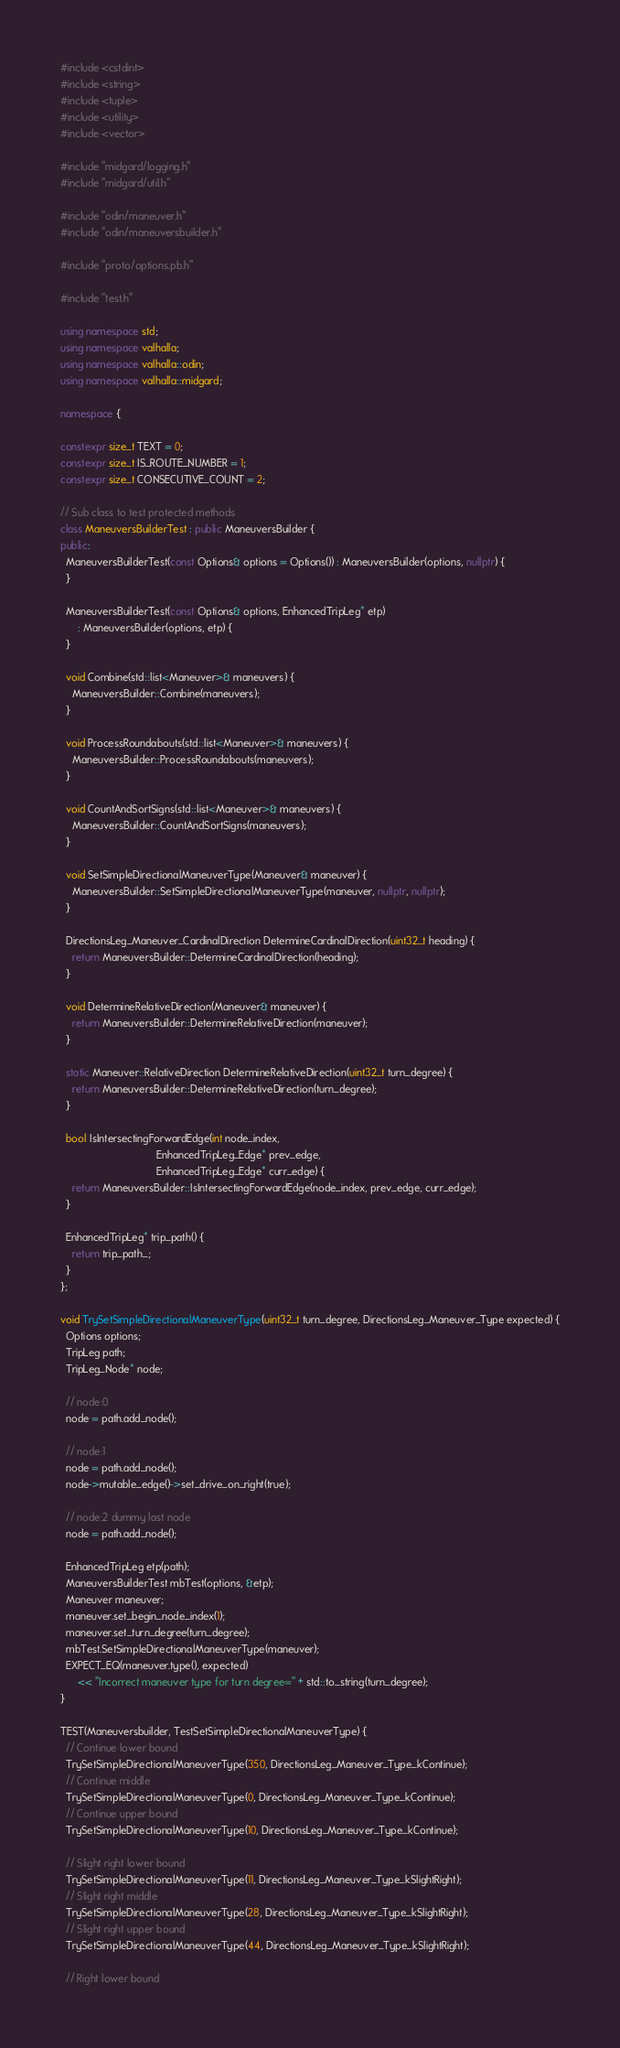Convert code to text. <code><loc_0><loc_0><loc_500><loc_500><_C++_>#include <cstdint>
#include <string>
#include <tuple>
#include <utility>
#include <vector>

#include "midgard/logging.h"
#include "midgard/util.h"

#include "odin/maneuver.h"
#include "odin/maneuversbuilder.h"

#include "proto/options.pb.h"

#include "test.h"

using namespace std;
using namespace valhalla;
using namespace valhalla::odin;
using namespace valhalla::midgard;

namespace {

constexpr size_t TEXT = 0;
constexpr size_t IS_ROUTE_NUMBER = 1;
constexpr size_t CONSECUTIVE_COUNT = 2;

// Sub class to test protected methods
class ManeuversBuilderTest : public ManeuversBuilder {
public:
  ManeuversBuilderTest(const Options& options = Options()) : ManeuversBuilder(options, nullptr) {
  }

  ManeuversBuilderTest(const Options& options, EnhancedTripLeg* etp)
      : ManeuversBuilder(options, etp) {
  }

  void Combine(std::list<Maneuver>& maneuvers) {
    ManeuversBuilder::Combine(maneuvers);
  }

  void ProcessRoundabouts(std::list<Maneuver>& maneuvers) {
    ManeuversBuilder::ProcessRoundabouts(maneuvers);
  }

  void CountAndSortSigns(std::list<Maneuver>& maneuvers) {
    ManeuversBuilder::CountAndSortSigns(maneuvers);
  }

  void SetSimpleDirectionalManeuverType(Maneuver& maneuver) {
    ManeuversBuilder::SetSimpleDirectionalManeuverType(maneuver, nullptr, nullptr);
  }

  DirectionsLeg_Maneuver_CardinalDirection DetermineCardinalDirection(uint32_t heading) {
    return ManeuversBuilder::DetermineCardinalDirection(heading);
  }

  void DetermineRelativeDirection(Maneuver& maneuver) {
    return ManeuversBuilder::DetermineRelativeDirection(maneuver);
  }

  static Maneuver::RelativeDirection DetermineRelativeDirection(uint32_t turn_degree) {
    return ManeuversBuilder::DetermineRelativeDirection(turn_degree);
  }

  bool IsIntersectingForwardEdge(int node_index,
                                 EnhancedTripLeg_Edge* prev_edge,
                                 EnhancedTripLeg_Edge* curr_edge) {
    return ManeuversBuilder::IsIntersectingForwardEdge(node_index, prev_edge, curr_edge);
  }

  EnhancedTripLeg* trip_path() {
    return trip_path_;
  }
};

void TrySetSimpleDirectionalManeuverType(uint32_t turn_degree, DirectionsLeg_Maneuver_Type expected) {
  Options options;
  TripLeg path;
  TripLeg_Node* node;

  // node:0
  node = path.add_node();

  // node:1
  node = path.add_node();
  node->mutable_edge()->set_drive_on_right(true);

  // node:2 dummy last node
  node = path.add_node();

  EnhancedTripLeg etp(path);
  ManeuversBuilderTest mbTest(options, &etp);
  Maneuver maneuver;
  maneuver.set_begin_node_index(1);
  maneuver.set_turn_degree(turn_degree);
  mbTest.SetSimpleDirectionalManeuverType(maneuver);
  EXPECT_EQ(maneuver.type(), expected)
      << "Incorrect maneuver type for turn degree=" + std::to_string(turn_degree);
}

TEST(Maneuversbuilder, TestSetSimpleDirectionalManeuverType) {
  // Continue lower bound
  TrySetSimpleDirectionalManeuverType(350, DirectionsLeg_Maneuver_Type_kContinue);
  // Continue middle
  TrySetSimpleDirectionalManeuverType(0, DirectionsLeg_Maneuver_Type_kContinue);
  // Continue upper bound
  TrySetSimpleDirectionalManeuverType(10, DirectionsLeg_Maneuver_Type_kContinue);

  // Slight right lower bound
  TrySetSimpleDirectionalManeuverType(11, DirectionsLeg_Maneuver_Type_kSlightRight);
  // Slight right middle
  TrySetSimpleDirectionalManeuverType(28, DirectionsLeg_Maneuver_Type_kSlightRight);
  // Slight right upper bound
  TrySetSimpleDirectionalManeuverType(44, DirectionsLeg_Maneuver_Type_kSlightRight);

  // Right lower bound</code> 